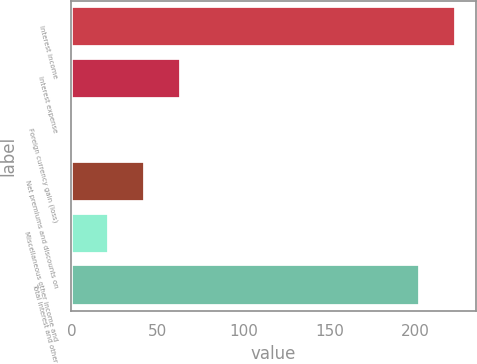<chart> <loc_0><loc_0><loc_500><loc_500><bar_chart><fcel>Interest income<fcel>Interest expense<fcel>Foreign currency gain (loss)<fcel>Net premiums and discounts on<fcel>Miscellaneous other income and<fcel>Total interest and other<nl><fcel>223.9<fcel>63.7<fcel>1<fcel>42.8<fcel>21.9<fcel>203<nl></chart> 